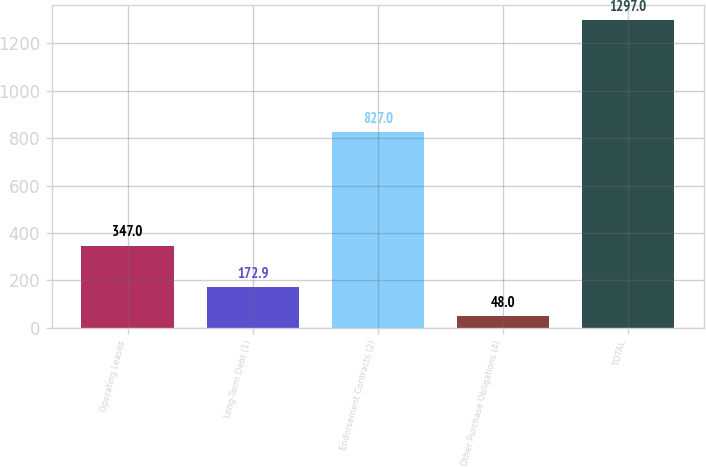Convert chart. <chart><loc_0><loc_0><loc_500><loc_500><bar_chart><fcel>Operating Leases<fcel>Long-Term Debt (1)<fcel>Endorsement Contracts (2)<fcel>Other Purchase Obligations (4)<fcel>TOTAL<nl><fcel>347<fcel>172.9<fcel>827<fcel>48<fcel>1297<nl></chart> 